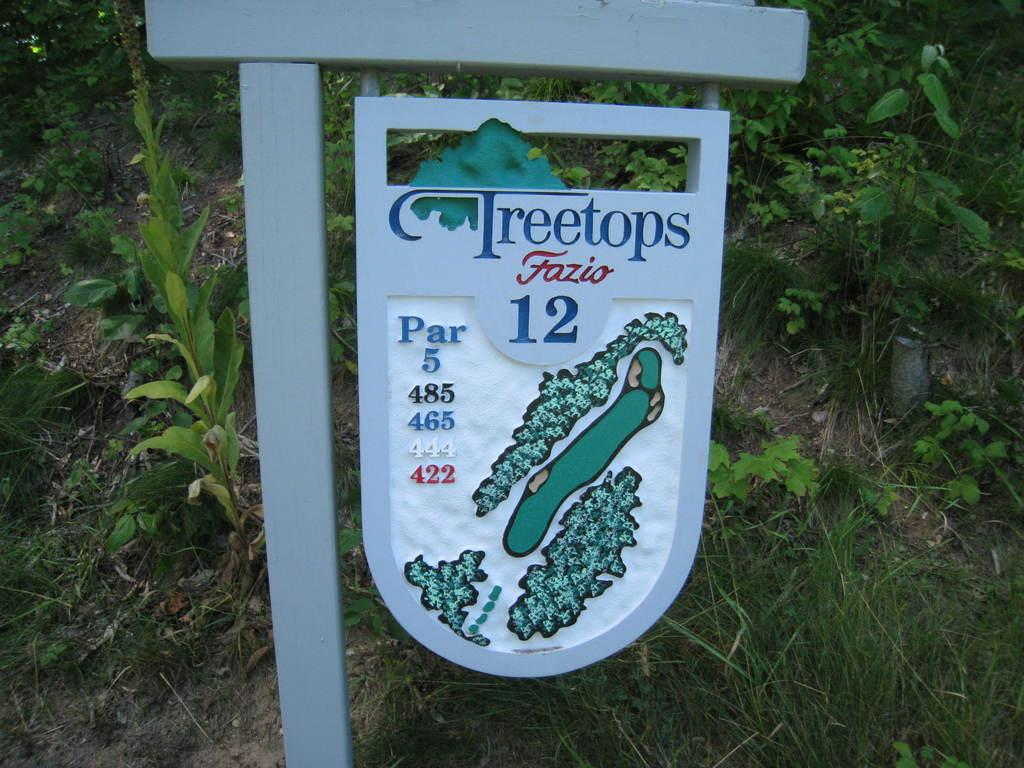What object is made of wood and present in the image? There is a wooden stick in the image, and a wooden board is attached to it. What is depicted on the wooden board? There is a route map on the wooden board. What can be found at the bottom of the image? Small plants and stones are visible at the bottom of the image. How many rings are visible on the wooden stick in the image? There are no rings visible on the wooden stick in the image. What type of plantation can be seen in the image? There is no plantation present in the image; it features a wooden stick with a board and a route map, along with small plants and stones at the bottom. 